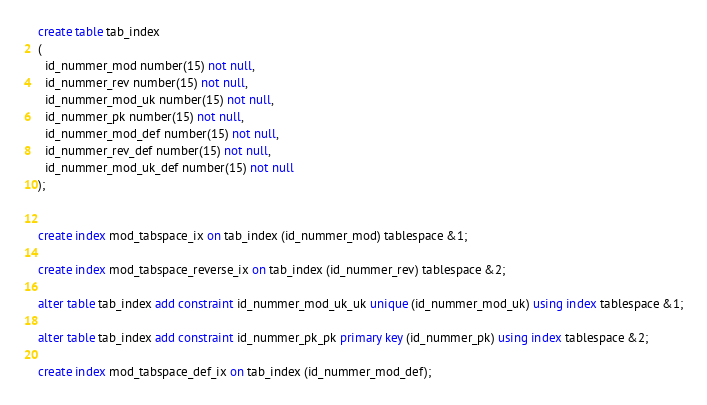Convert code to text. <code><loc_0><loc_0><loc_500><loc_500><_SQL_>create table tab_index
(
  id_nummer_mod number(15) not null,
  id_nummer_rev number(15) not null,
  id_nummer_mod_uk number(15) not null,
  id_nummer_pk number(15) not null,
  id_nummer_mod_def number(15) not null,
  id_nummer_rev_def number(15) not null,
  id_nummer_mod_uk_def number(15) not null
);


create index mod_tabspace_ix on tab_index (id_nummer_mod) tablespace &1; 

create index mod_tabspace_reverse_ix on tab_index (id_nummer_rev) tablespace &2;

alter table tab_index add constraint id_nummer_mod_uk_uk unique (id_nummer_mod_uk) using index tablespace &1;

alter table tab_index add constraint id_nummer_pk_pk primary key (id_nummer_pk) using index tablespace &2;

create index mod_tabspace_def_ix on tab_index (id_nummer_mod_def); 
</code> 